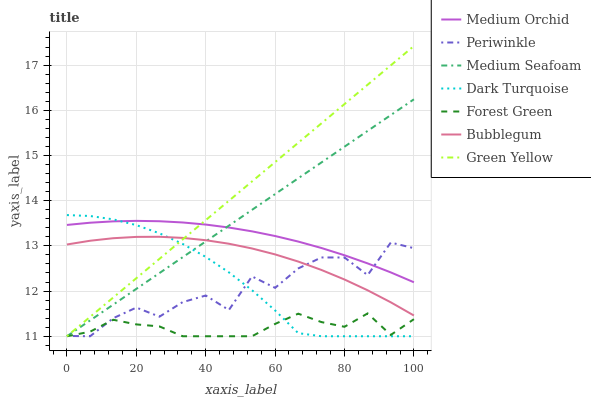Does Forest Green have the minimum area under the curve?
Answer yes or no. Yes. Does Green Yellow have the maximum area under the curve?
Answer yes or no. Yes. Does Medium Orchid have the minimum area under the curve?
Answer yes or no. No. Does Medium Orchid have the maximum area under the curve?
Answer yes or no. No. Is Medium Seafoam the smoothest?
Answer yes or no. Yes. Is Periwinkle the roughest?
Answer yes or no. Yes. Is Medium Orchid the smoothest?
Answer yes or no. No. Is Medium Orchid the roughest?
Answer yes or no. No. Does Dark Turquoise have the lowest value?
Answer yes or no. Yes. Does Bubblegum have the lowest value?
Answer yes or no. No. Does Green Yellow have the highest value?
Answer yes or no. Yes. Does Medium Orchid have the highest value?
Answer yes or no. No. Is Forest Green less than Bubblegum?
Answer yes or no. Yes. Is Medium Orchid greater than Bubblegum?
Answer yes or no. Yes. Does Green Yellow intersect Medium Seafoam?
Answer yes or no. Yes. Is Green Yellow less than Medium Seafoam?
Answer yes or no. No. Is Green Yellow greater than Medium Seafoam?
Answer yes or no. No. Does Forest Green intersect Bubblegum?
Answer yes or no. No. 